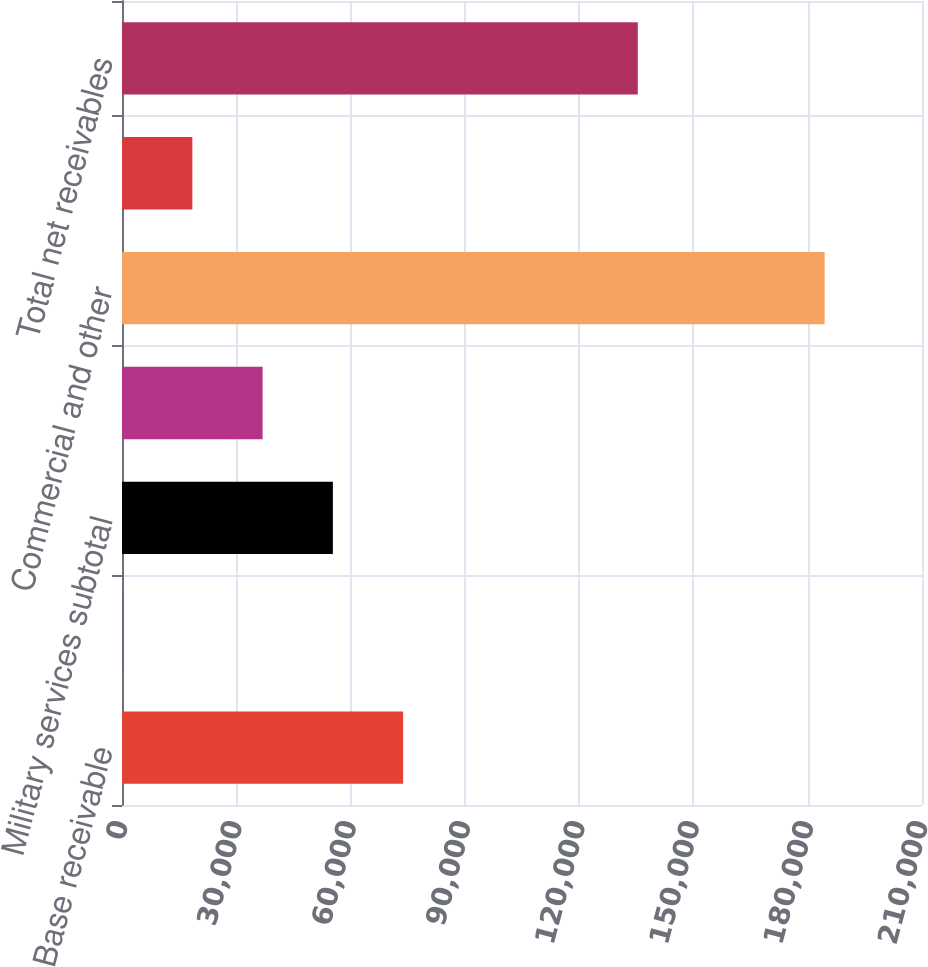Convert chart to OTSL. <chart><loc_0><loc_0><loc_500><loc_500><bar_chart><fcel>Base receivable<fcel>Change orders<fcel>Military services subtotal<fcel>Medicare<fcel>Commercial and other<fcel>Allowance for doubtful<fcel>Total net receivables<nl><fcel>73795.2<fcel>28<fcel>55353.4<fcel>36911.6<fcel>184446<fcel>18469.8<fcel>135398<nl></chart> 